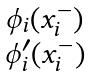<formula> <loc_0><loc_0><loc_500><loc_500>\begin{smallmatrix} \phi _ { i } ( x _ { i } ^ { - } ) \\ \phi _ { i } ^ { \prime } ( x _ { i } ^ { - } ) \end{smallmatrix}</formula> 